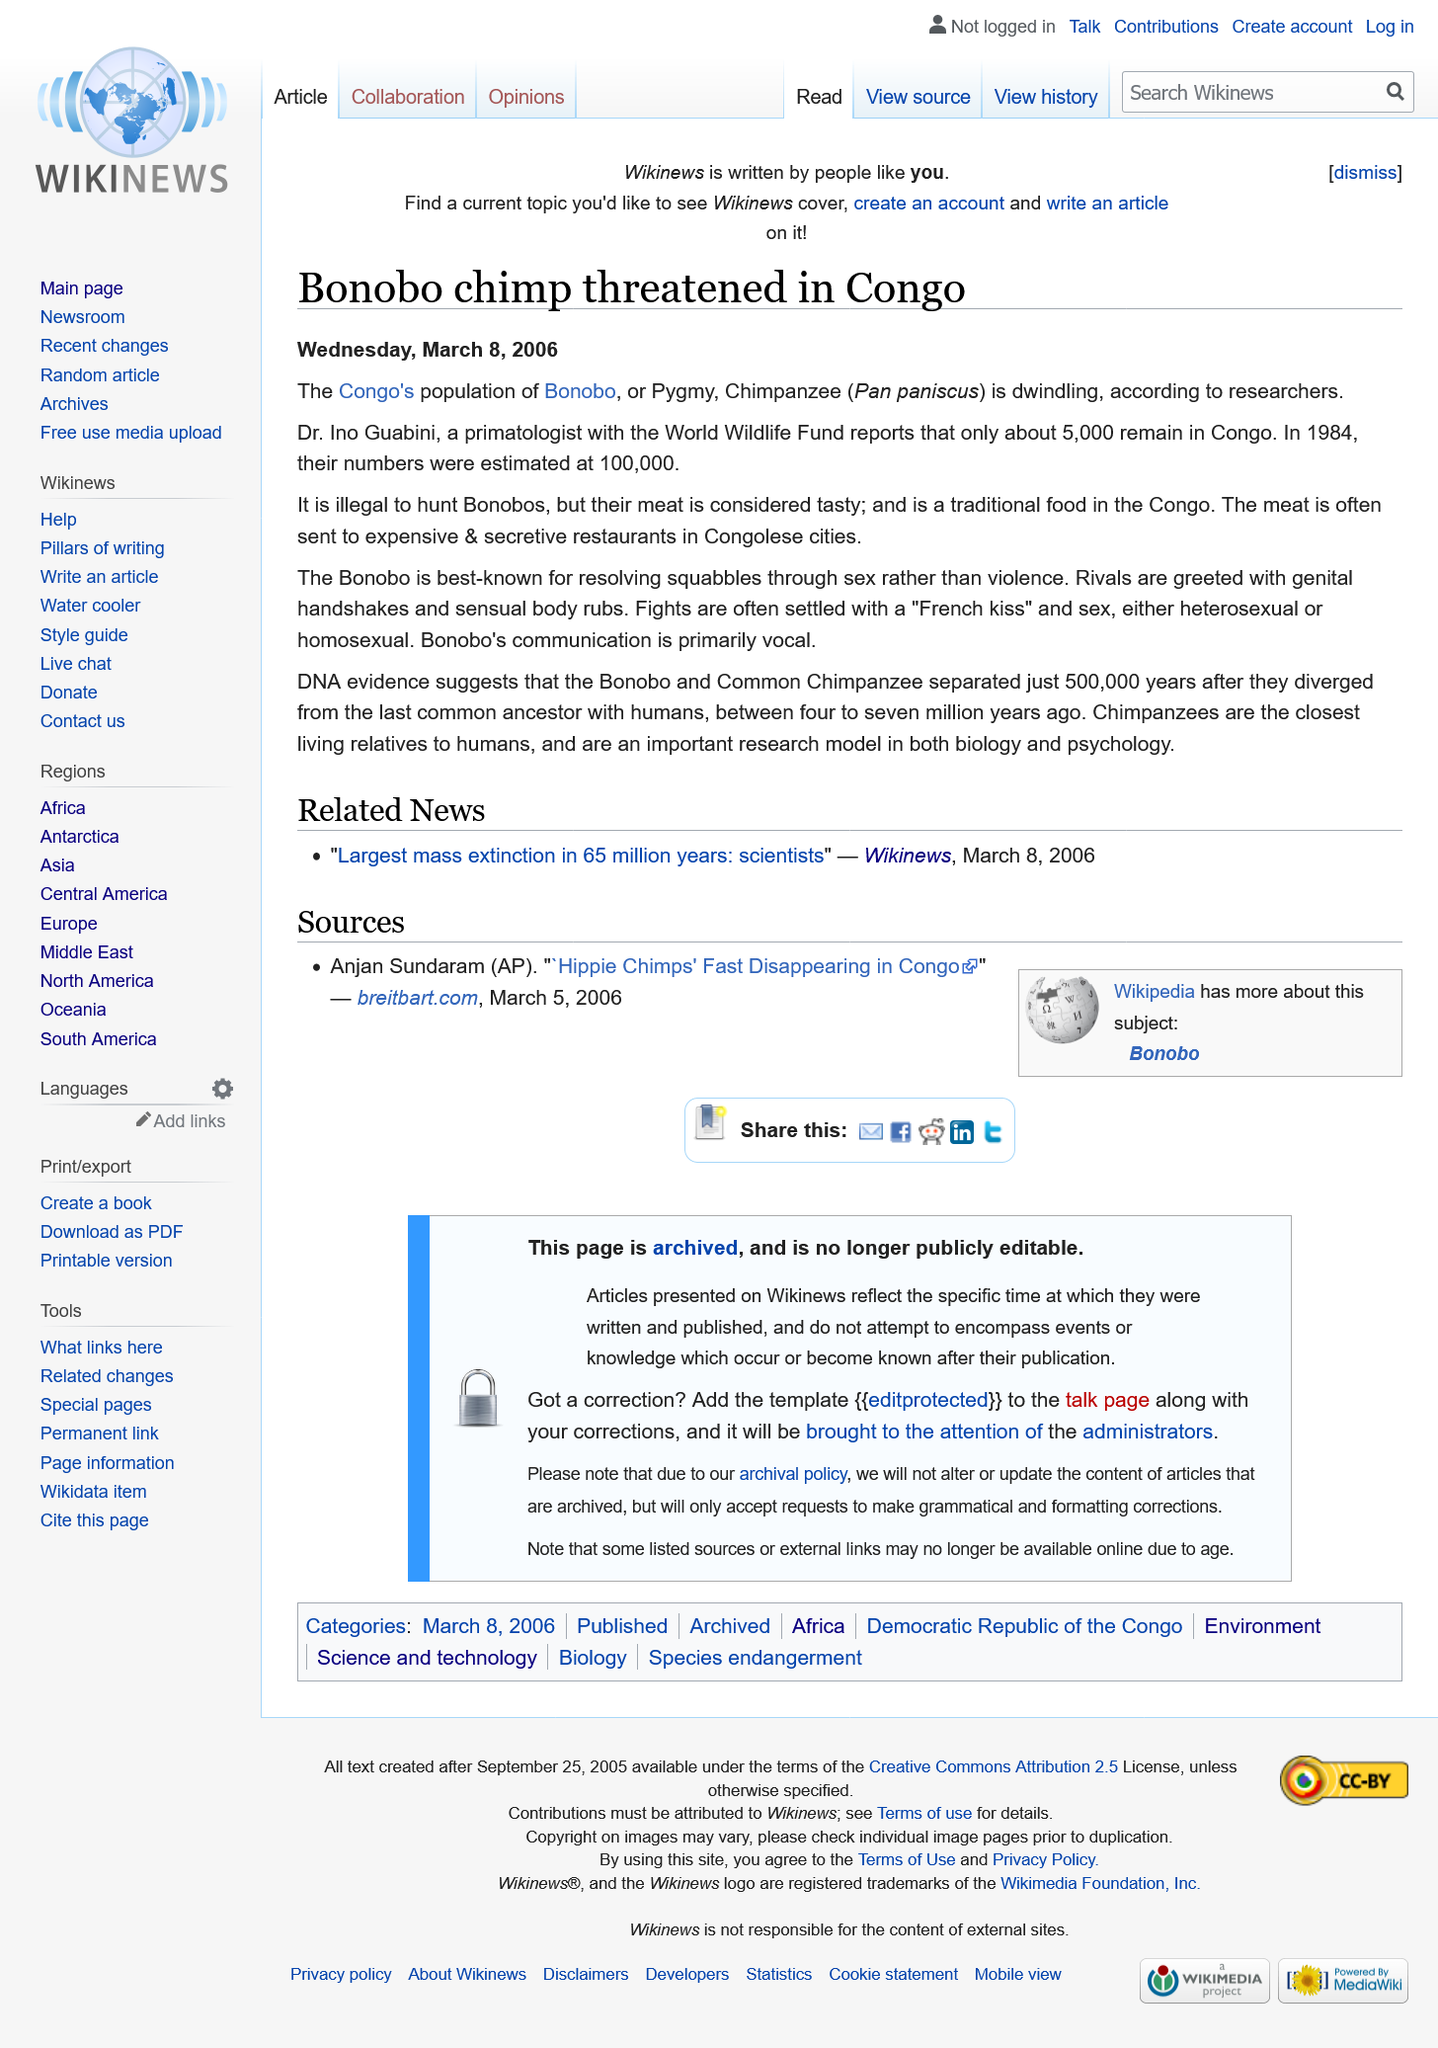Draw attention to some important aspects in this diagram. Bonobos often settle fights through the use of a French kiss and sexual intercourse. The reported number of Bonobos in Congo is 5,000, and it is illegal to hunt them. Bonobos are native to the Congo, and their meat is a traditional food there. 